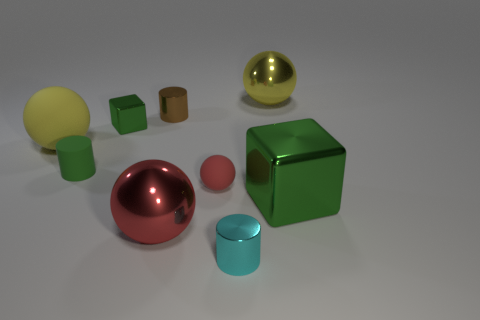How many green cubes must be subtracted to get 1 green cubes? 1 Subtract all blocks. How many objects are left? 7 Subtract 0 purple spheres. How many objects are left? 9 Subtract all tiny red matte things. Subtract all yellow balls. How many objects are left? 6 Add 6 tiny cubes. How many tiny cubes are left? 7 Add 8 gray shiny objects. How many gray shiny objects exist? 8 